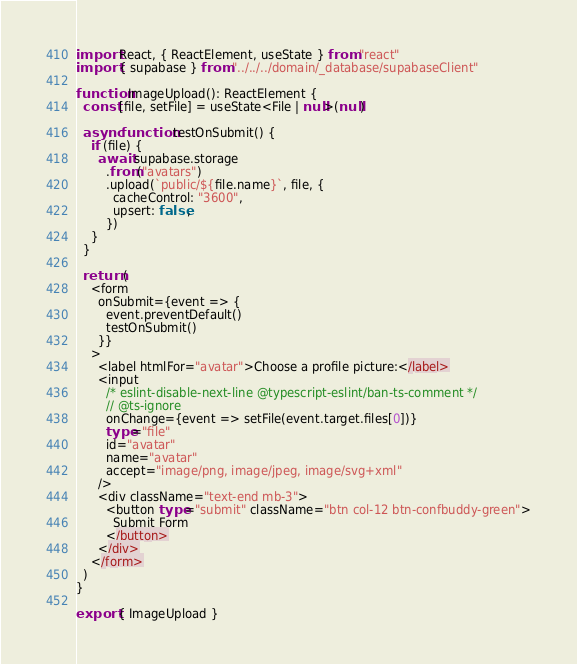<code> <loc_0><loc_0><loc_500><loc_500><_TypeScript_>import React, { ReactElement, useState } from "react"
import { supabase } from "../../../domain/_database/supabaseClient"

function ImageUpload(): ReactElement {
  const [file, setFile] = useState<File | null>(null)

  async function testOnSubmit() {
    if (file) {
      await supabase.storage
        .from("avatars")
        .upload(`public/${file.name}`, file, {
          cacheControl: "3600",
          upsert: false,
        })
    }
  }

  return (
    <form
      onSubmit={event => {
        event.preventDefault()
        testOnSubmit()
      }}
    >
      <label htmlFor="avatar">Choose a profile picture:</label>
      <input
        /* eslint-disable-next-line @typescript-eslint/ban-ts-comment */
        // @ts-ignore
        onChange={event => setFile(event.target.files[0])}
        type="file"
        id="avatar"
        name="avatar"
        accept="image/png, image/jpeg, image/svg+xml"
      />
      <div className="text-end mb-3">
        <button type="submit" className="btn col-12 btn-confbuddy-green">
          Submit Form
        </button>
      </div>
    </form>
  )
}

export { ImageUpload }
</code> 